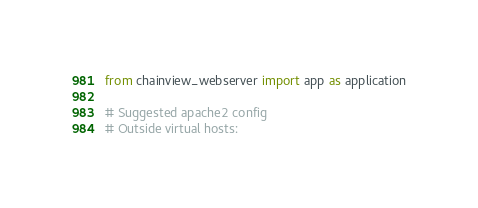<code> <loc_0><loc_0><loc_500><loc_500><_Python_>from chainview_webserver import app as application

# Suggested apache2 config
# Outside virtual hosts:</code> 